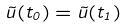Convert formula to latex. <formula><loc_0><loc_0><loc_500><loc_500>\vec { u } ( t _ { 0 } ) = \vec { u } ( t _ { 1 } )</formula> 